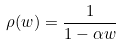Convert formula to latex. <formula><loc_0><loc_0><loc_500><loc_500>\rho ( w ) = \frac { 1 } { 1 - \alpha w }</formula> 